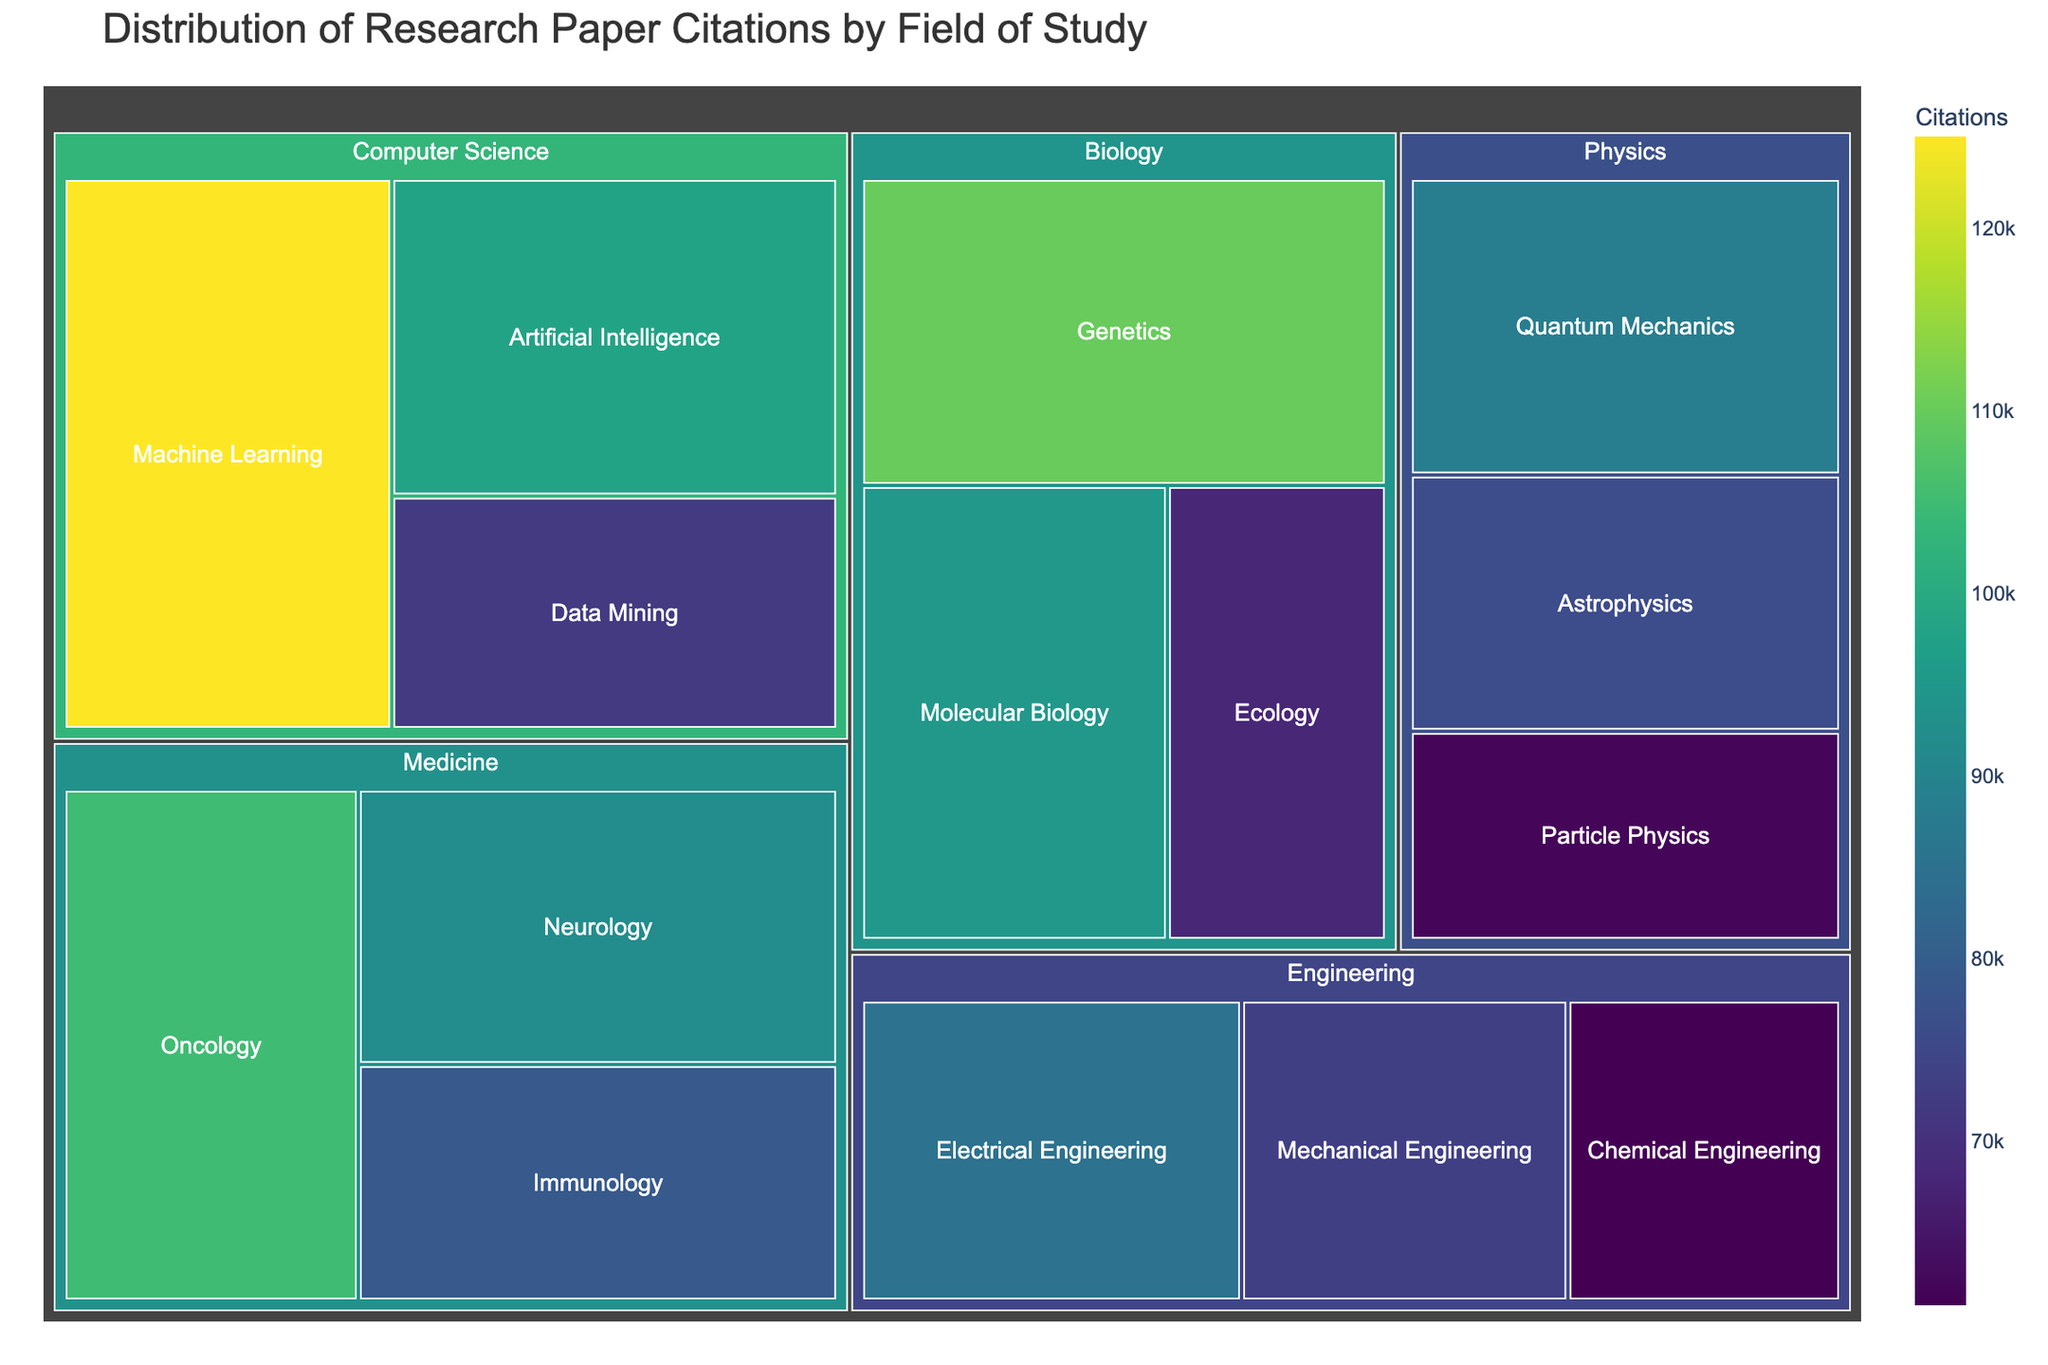What field has the subfield with the most citations? First, identify the subfield with the highest value, which is "Machine Learning" with 125,000 citations. Then, check under which field it belongs, which is "Computer Science".
Answer: Computer Science Which subfield in Biology has the highest number of citations? Look under the field "Biology" and identify the subfield with the highest citations. Among "Genetics," "Molecular Biology," and "Ecology," "Genetics" has the highest with 110,000 citations.
Answer: Genetics How many subfields have more than 90,000 citations? Count the subfields with citations greater than 90,000. Those are "Machine Learning," "Artificial Intelligence," "Genetics," "Molecular Biology," "Oncology," and "Neurology," giving a total of 6 subfields.
Answer: 6 What is the total number of citations for the subfields in Medicine? Sum up the citations for "Oncology" (105,000), "Neurology" (92,000), and "Immunology" (79,000). The total is 105,000 + 92,000 + 79,000 = 276,000.
Answer: 276,000 Compare the number of citations in the fields of Physics and Engineering; which has more? Calculate the total citations for each field. Physics: (88,000 + 76,000 + 62,000) = 226,000. Engineering: (85,000 + 73,000 + 61,000) = 219,000. Physics has more citations.
Answer: Physics Which field has the widest distribution in the color scale? The color scale reflects the number of citations. For the field with the widest range, look at the differences in citations among its subfields. "Computer Science" ranges from 125,000 to 72,000, which shows a significant spread.
Answer: Computer Science What subfield in Medicine has the fewest citations? Check the subfields under Medicine and identify the one with the lowest value. "Immunology" has the fewest citations with 79,000.
Answer: Immunology Which has more citations: "Quantum Mechanics" or "Data Mining"? Directly compare the citations of "Quantum Mechanics" (88,000) and "Data Mining" (72,000). "Quantum Mechanics" has more.
Answer: Quantum Mechanics Is the sum of citations for "Data Mining" and "Molecular Biology" greater than the citations for "Genetics"? Sum the citations of "Data Mining" (72,000) and "Molecular Biology" (95,000): 72,000 + 95,000 = 167,000. Compare this with "Genetics" (110,000). 167,000 is indeed greater than 110,000.
Answer: Yes How many subfields fall under each field in the treemap? Count the subfields listed under each field: "Computer Science" has 3, "Biology" has 3, "Physics" has 3, "Medicine" has 3, and "Engineering" has 3.
Answer: 3 each 